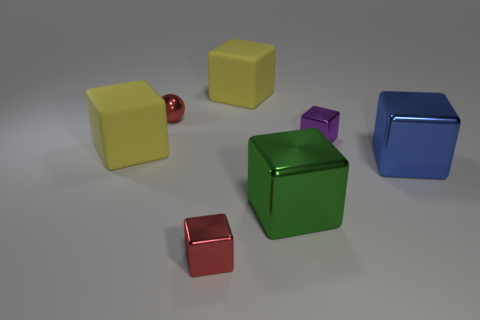There is a object that is the same color as the tiny shiny ball; what is its shape?
Provide a short and direct response. Cube. There is a big rubber thing to the right of the small red shiny cube; does it have the same shape as the large green thing?
Offer a very short reply. Yes. Are there more balls to the left of the large blue shiny cube than small red metal cylinders?
Your answer should be compact. Yes. Are there any shiny things in front of the red metal cube?
Give a very brief answer. No. Do the green metallic thing and the red cube have the same size?
Your response must be concise. No. The red shiny thing that is the same shape as the purple thing is what size?
Provide a succinct answer. Small. Are there any other things that are the same size as the blue object?
Make the answer very short. Yes. The tiny red thing in front of the large matte thing that is in front of the tiny purple cube is made of what material?
Offer a very short reply. Metal. Does the large blue object have the same shape as the green metallic object?
Provide a succinct answer. Yes. What number of tiny objects are in front of the blue cube and right of the red cube?
Offer a very short reply. 0. 